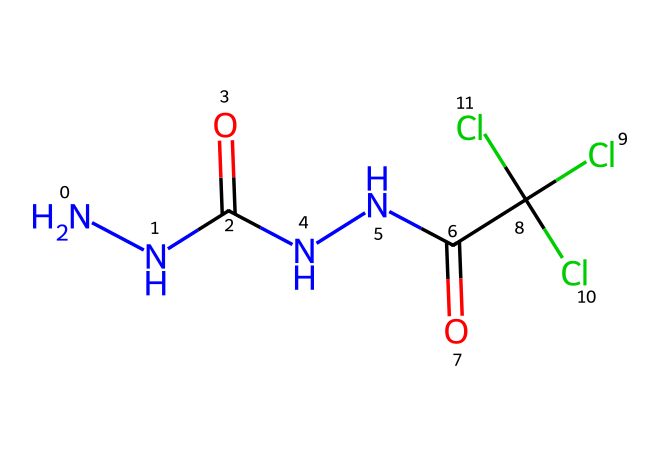What is the total number of nitrogen atoms in this chemical? The SMILES representation indicates there are two occurrences of 'N', which represent nitrogen atoms. Counting them gives a total of two nitrogen atoms.
Answer: 2 How many chlorine atoms are present in this chemical? The SMILES representation shows three instances of 'Cl', indicating the presence of three chlorine atoms. Counting them gives a total of three chlorine atoms.
Answer: 3 What type of functional groups are evident in this chemical structure? The chemical has two carbonyl groups (C=O) due to the occurrence of 'C(=O)' twice, indicating the presence of amides derived from hydrazine.
Answer: carbonyl What is the total number of carbon atoms in this chemical? In the SMILES representation, there are two occurrences of 'C' which represent carbon atoms, confirming that there are two carbon atoms in total.
Answer: 2 What type of chemical is represented by the hydrazine moiety in this structure? The structure has an amine portion characterized by the presence of the two 'N's connected directly, which is a defining feature of hydrazines.
Answer: hydrazine What does the presence of multiple chlorine atoms suggest about the properties of this chemical? The presence of multiple chlorine atoms in a compound usually indicates that it can impart fire retardant properties, as chlorine is known to enhance flame resistance.
Answer: fire retardant 